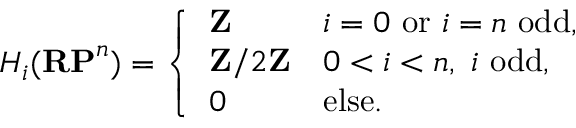Convert formula to latex. <formula><loc_0><loc_0><loc_500><loc_500>H _ { i } ( R P ^ { n } ) = { \left \{ \begin{array} { l l } { Z } & { i = 0 { o r } i = n { o d d , } } \\ { Z / 2 Z } & { 0 < i < n , \ i \ { o d d , } } \\ { 0 } & { e l s e . } \end{array} }</formula> 